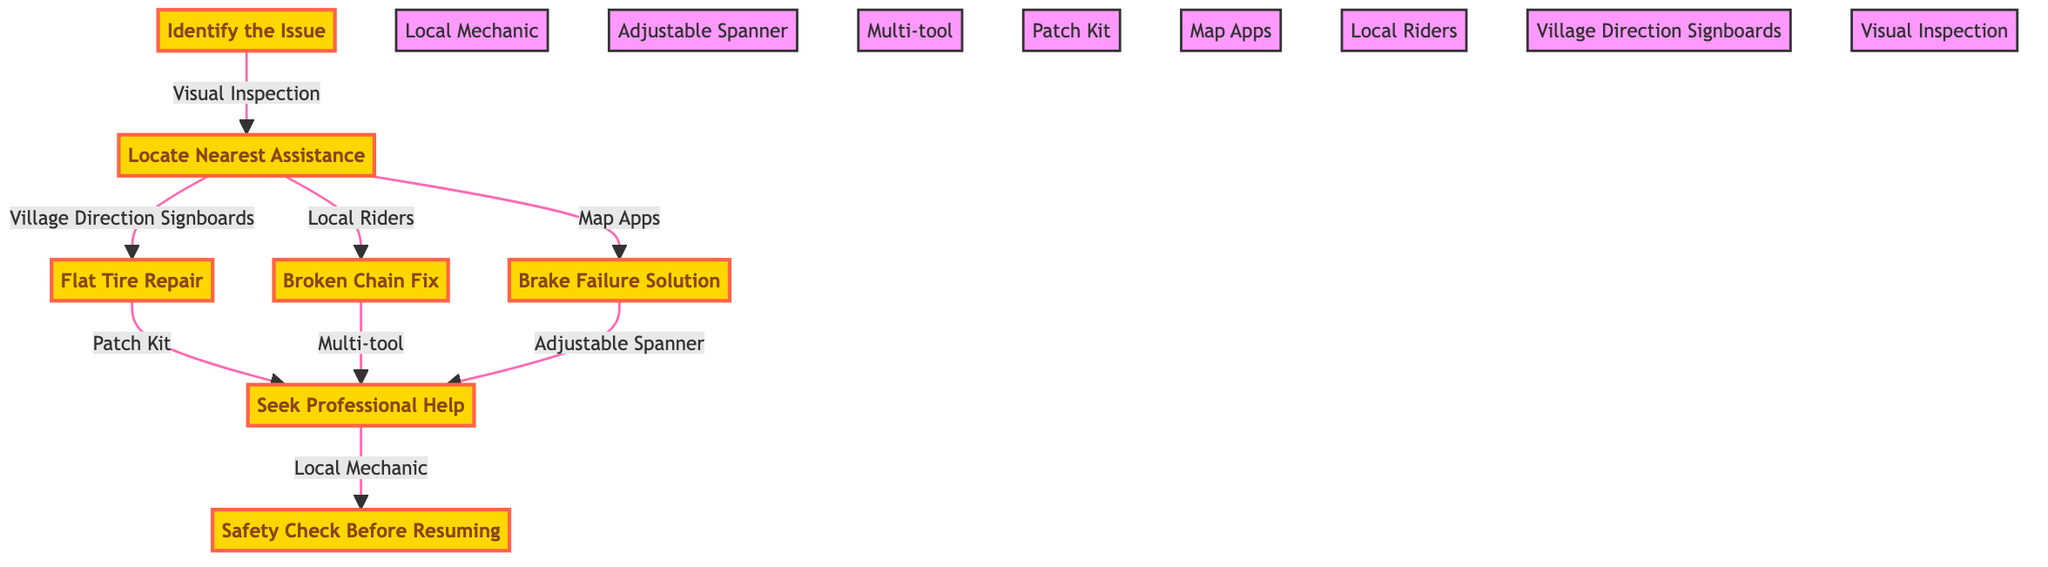What is the first step in the pathway? The first step is "Identify the Issue," which is indicated at the top of the diagram as the starting point of the flow.
Answer: Identify the Issue How many total steps are there in the pathway? The diagram shows a total of seven distinct steps, labeled from one to seven in the pathway.
Answer: 7 What tool is used for the flat tire repair? According to the diagram, the "Patch Kit" is explicitly mentioned as the tool used for flat tire repair, connected to the step of handling a flat tire.
Answer: Patch Kit Which step follows the "Seek Professional Help"? The immediate next step indicated in the flow after "Seek Professional Help" is "Safety Check Before Resuming," showing that it’s essential to check safety before continuing.
Answer: Safety Check Before Resuming How does one locate assistance according to the diagram? The diagram provides three methods to locate assistance, including "Village Direction Signboards," "Local Riders," and "Map Apps," which are all connected to the locating assistance step.
Answer: Village Direction Signboards, Local Riders, Map Apps If a broken chain is identified, which tool can be used for repair? The diagram shows a "Multi-tool" as an option for fixing a broken chain, indicated under the corresponding step dealing with broken chains.
Answer: Multi-tool Which step is associated with brake failure repairs? The diagram clearly denotes "Brake Failure Solution" as the specific step to address brake issues, indicating it follows the finding of assistance step.
Answer: Brake Failure Solution How many ways are there to fix the identified issues, based on the nearest assistance? The diagram provides three distinct repair paths that can be pursued based on the type of breakdown (flat tire, broken chain, brake failure), indicating three approaches for fixes.
Answer: 3 